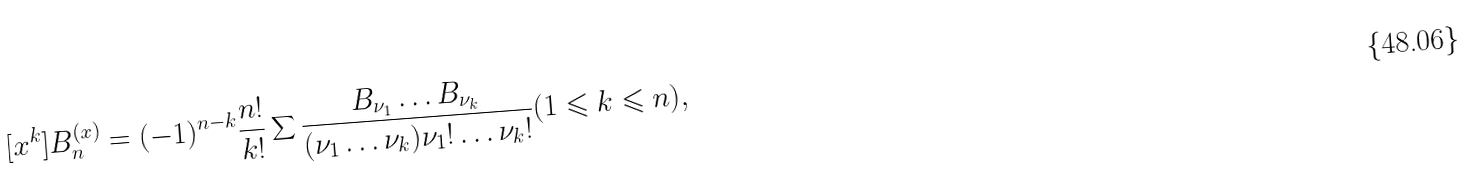<formula> <loc_0><loc_0><loc_500><loc_500>[ x ^ { k } ] B _ { n } ^ { ( x ) } = ( - 1 ) ^ { n - k } \frac { n ! } { k ! } \sum \frac { B _ { \nu _ { 1 } } \dots B _ { \nu _ { k } } } { ( \nu _ { 1 } \dots \nu _ { k } ) \nu _ { 1 } ! \dots \nu _ { k } ! } ( 1 \leqslant k \leqslant n ) ,</formula> 